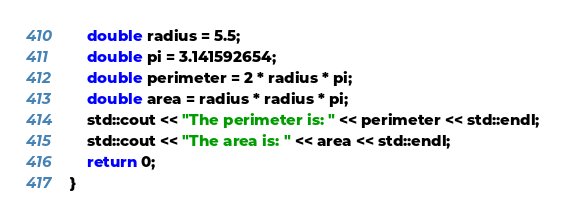<code> <loc_0><loc_0><loc_500><loc_500><_C++_>    double radius = 5.5;
    double pi = 3.141592654;
    double perimeter = 2 * radius * pi;
    double area = radius * radius * pi;
    std::cout << "The perimeter is: " << perimeter << std::endl;
    std::cout << "The area is: " << area << std::endl;
    return 0;
}</code> 